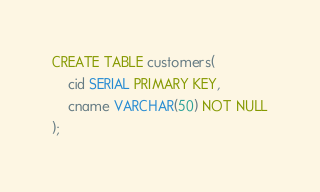Convert code to text. <code><loc_0><loc_0><loc_500><loc_500><_SQL_>CREATE TABLE customers(
    cid SERIAL PRIMARY KEY, 
    cname VARCHAR(50) NOT NULL
);</code> 